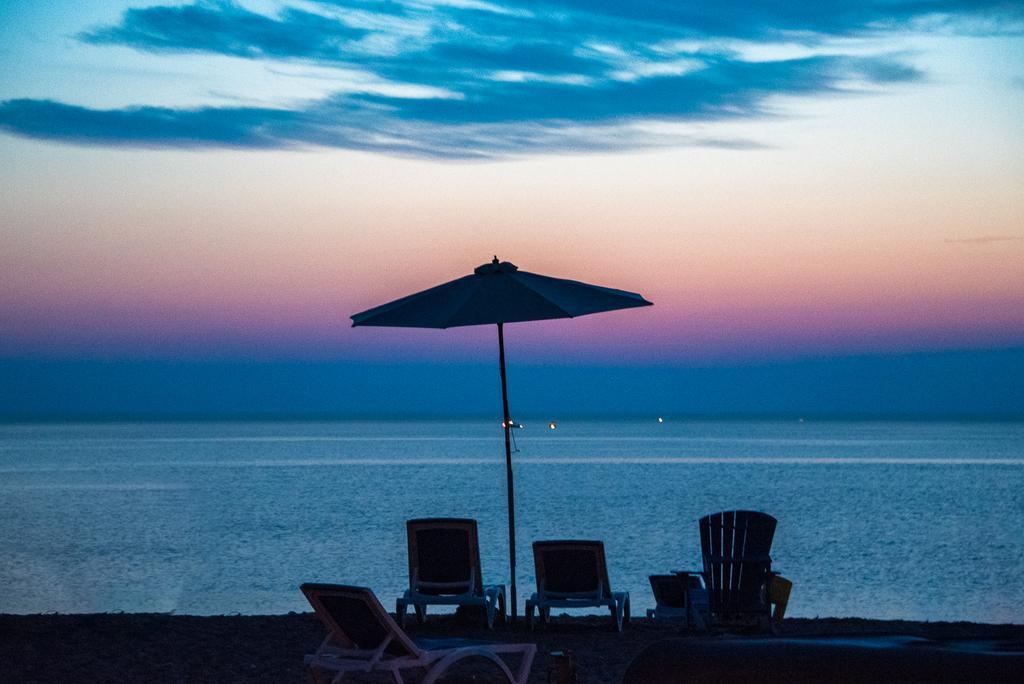In one or two sentences, can you explain what this image depicts? In this image I can see few chairs, I can also see an umbrella. Background I can see the water, and the sky is in blue, white and orange color. 